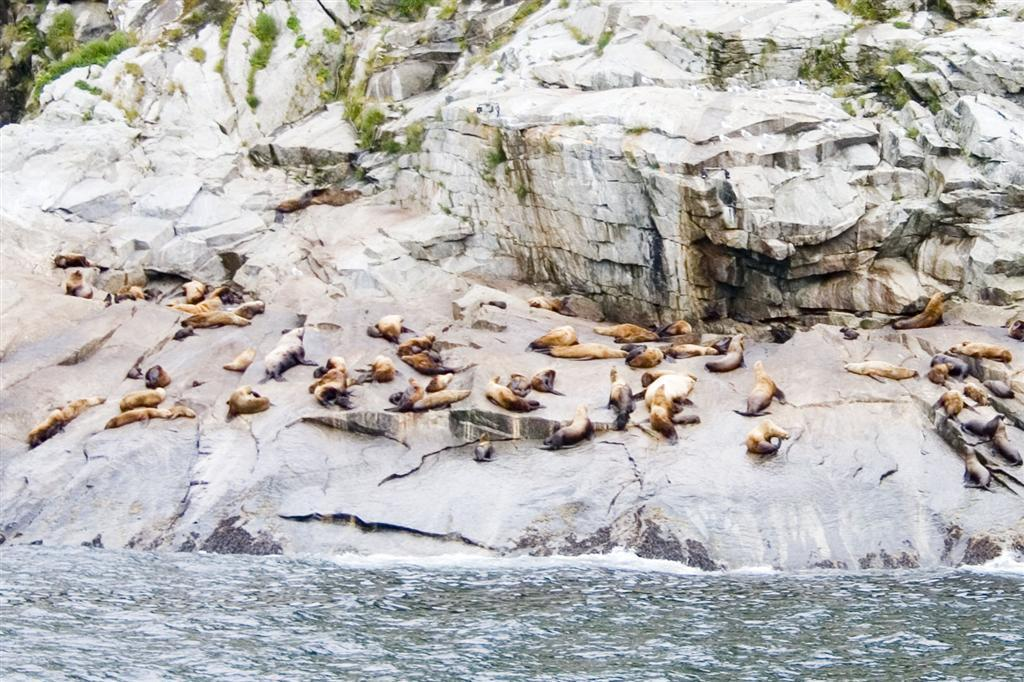What animals can be seen in the image? There is a group of seals on a rock in the image. What type of vegetation is visible in the image? Grass is visible at the top of the image. What natural element is present at the bottom of the image? Water is flowing at the bottom of the image. What advice does the dad give to the cattle in the image? There are no cattle or dad present in the image, so it is not possible to answer that question. 